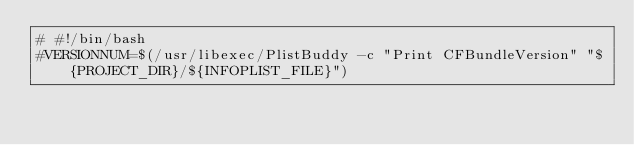<code> <loc_0><loc_0><loc_500><loc_500><_Bash_># #!/bin/bash
#VERSIONNUM=$(/usr/libexec/PlistBuddy -c "Print CFBundleVersion" "${PROJECT_DIR}/${INFOPLIST_FILE}")</code> 